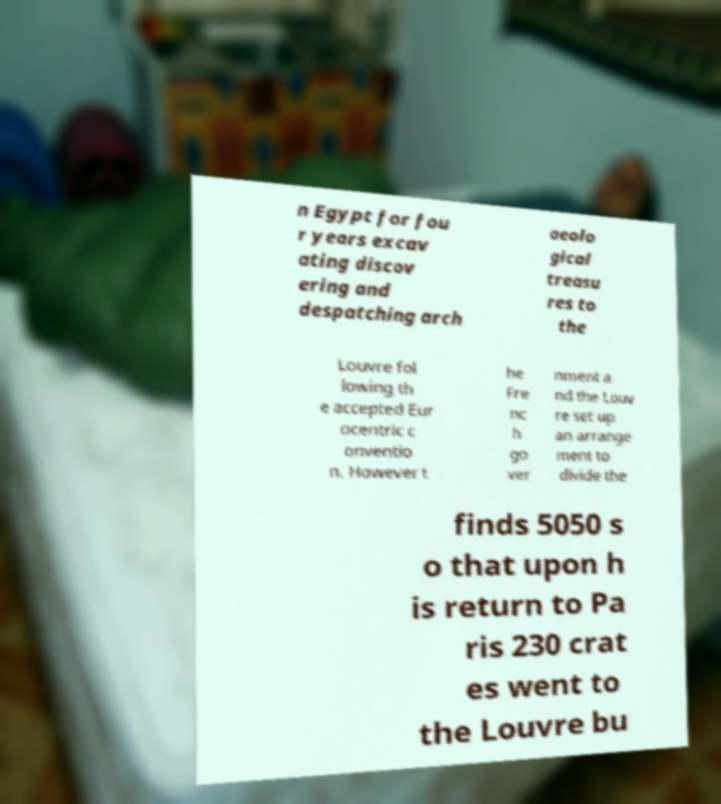Can you accurately transcribe the text from the provided image for me? n Egypt for fou r years excav ating discov ering and despatching arch aeolo gical treasu res to the Louvre fol lowing th e accepted Eur ocentric c onventio n. However t he Fre nc h go ver nment a nd the Louv re set up an arrange ment to divide the finds 5050 s o that upon h is return to Pa ris 230 crat es went to the Louvre bu 